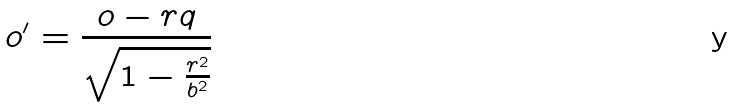<formula> <loc_0><loc_0><loc_500><loc_500>o ^ { \prime } = \frac { o - r q } { \sqrt { 1 - \frac { r ^ { 2 } } { b ^ { 2 } } } }</formula> 